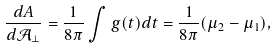Convert formula to latex. <formula><loc_0><loc_0><loc_500><loc_500>\frac { d A } { d \mathcal { A } _ { \perp } } = \frac { 1 } { 8 \pi } \int g ( t ) d t = \frac { 1 } { 8 \pi } ( \mu _ { 2 } - \mu _ { 1 } ) ,</formula> 